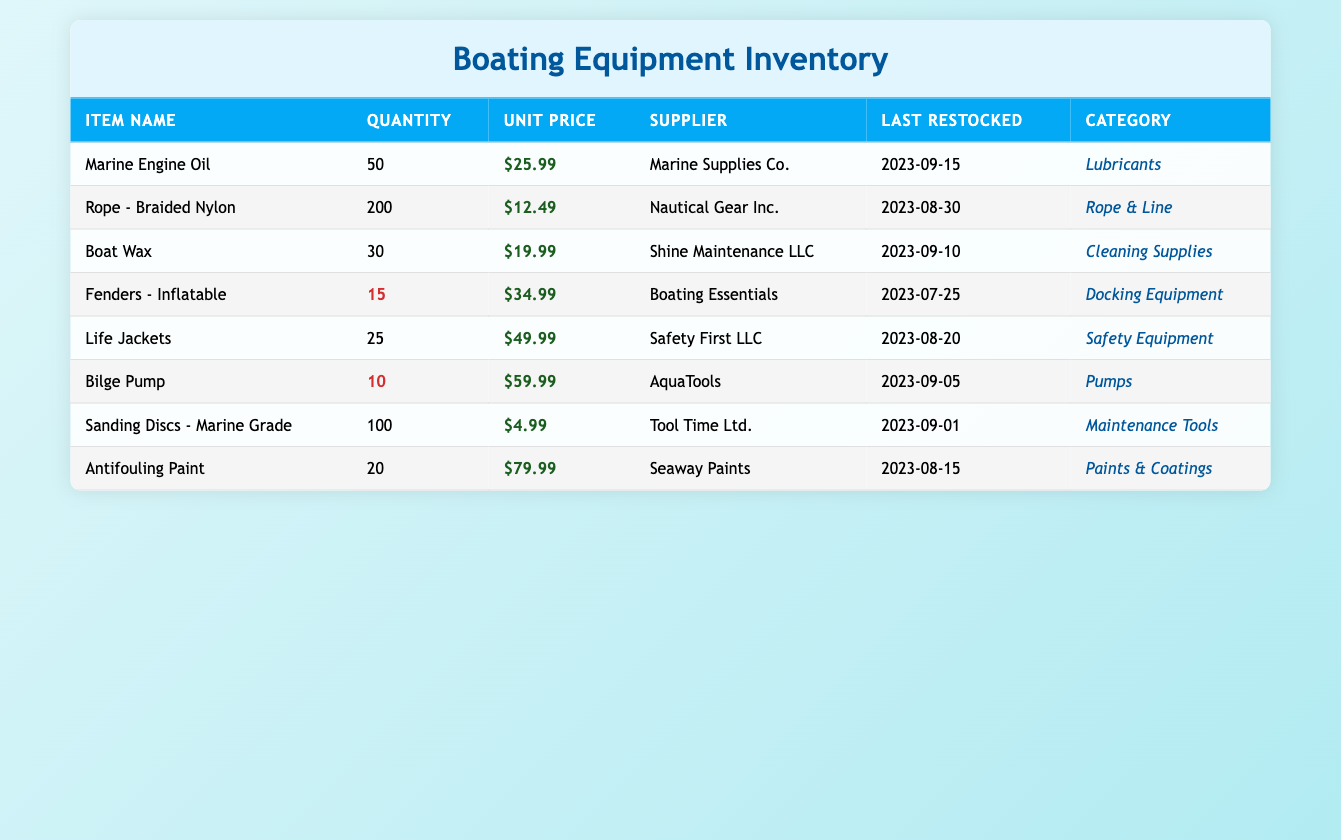What is the total quantity of maintenance supplies in the inventory? To find the total quantity, we need to sum up the quantities of all items listed in the table: 50 (Marine Engine Oil) + 200 (Rope - Braided Nylon) + 30 (Boat Wax) + 15 (Fenders - Inflatable) + 25 (Life Jackets) + 10 (Bilge Pump) + 100 (Sanding Discs - Marine Grade) + 20 (Antifouling Paint) = 450.
Answer: 450 Which item has the highest unit price? By checking the unit prices for all items, we find that Antifouling Paint has the highest unit price at $79.99, compared to the other prices listed in the table.
Answer: Antifouling Paint How many items have a quantity less than 20? Reviewing the quantities in the table, we see that only the Bilge Pump (10) and the Fenders - Inflatable (15) have quantities less than 20. Thus, there are 2 items fitting this criterion.
Answer: 2 Do Life Jackets have a lower unit price than Fenders - Inflatable? Checking the unit prices, Life Jackets are priced at $49.99 and Fenders - Inflatable are at $34.99. Since $49.99 is greater than $34.99, the statement is false.
Answer: No What is the average unit price of the items in the inventory? First, we calculate the total unit price: 25.99 + 12.49 + 19.99 + 34.99 + 49.99 + 59.99 + 4.99 + 79.99 =  288.42. Then we divide this by the number of items (8): 288.42 / 8 = 36.05.
Answer: 36.05 Which supplier provides the most products listed in the inventory? By checking the supplier for each item, we note that several suppliers are listed. However, counting items per supplier shows that Marine Supplies Co., Nautical Gear Inc., Shine Maintenance LLC, Boating Essentials, Safety First LLC, AquaTools, Tool Time Ltd., and Seaway Paints each provide one item; thus, no supplier stands out as providing more.
Answer: No supplier has more products Is the last restocked date for Bilge Pump more recent than that of Life Jackets? The last restocked date for the Bilge Pump is 2023-09-05 and for Life Jackets, it is 2023-08-20. Since 2023-09-05 is more recent than 2023-08-20, the statement is true.
Answer: Yes What is the total unit price of the items in the Safety Equipment category? The only item in the Safety Equipment category is Life Jackets, with a unit price of $49.99. Therefore, the total unit price for this category is simply $49.99.
Answer: 49.99 